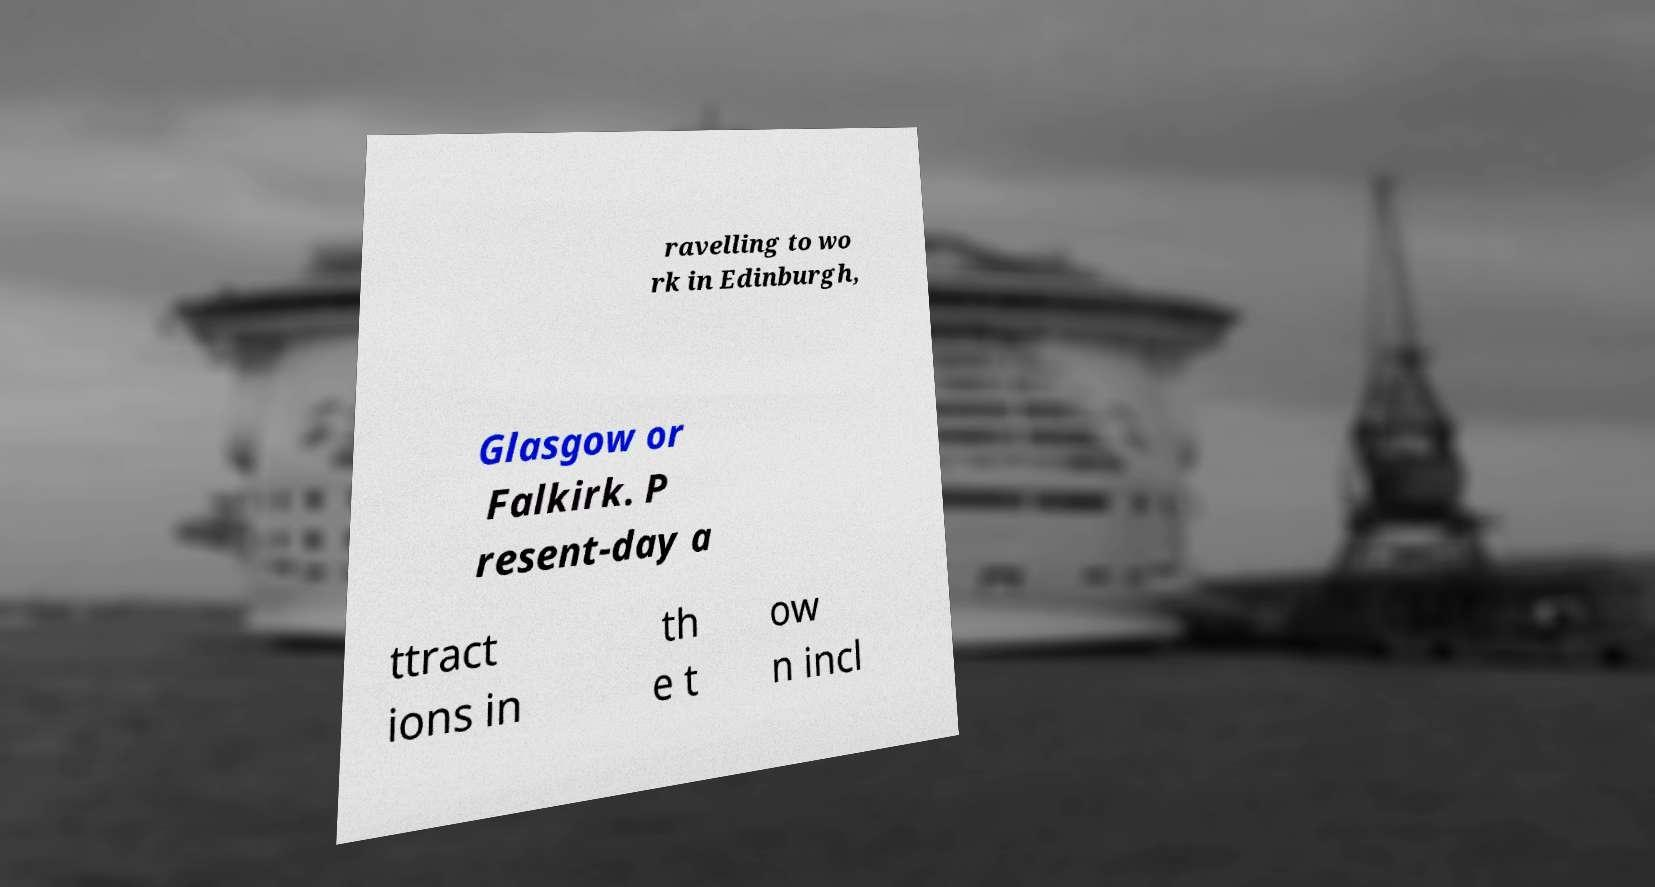What messages or text are displayed in this image? I need them in a readable, typed format. ravelling to wo rk in Edinburgh, Glasgow or Falkirk. P resent-day a ttract ions in th e t ow n incl 